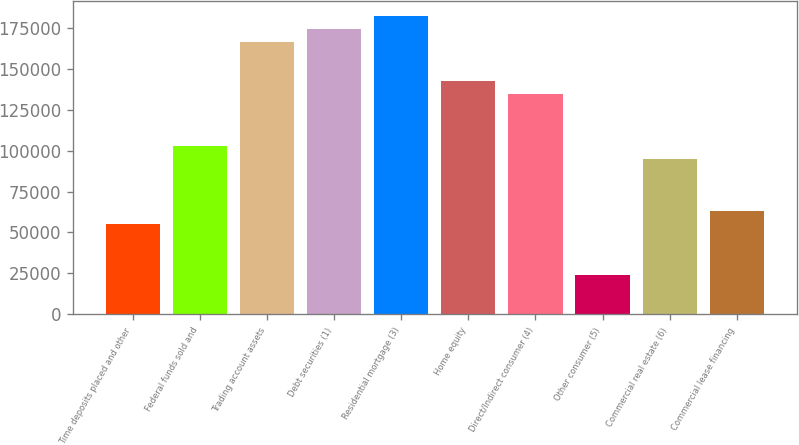Convert chart to OTSL. <chart><loc_0><loc_0><loc_500><loc_500><bar_chart><fcel>Time deposits placed and other<fcel>Federal funds sold and<fcel>Trading account assets<fcel>Debt securities (1)<fcel>Residential mortgage (3)<fcel>Home equity<fcel>Direct/Indirect consumer (4)<fcel>Other consumer (5)<fcel>Commercial real estate (6)<fcel>Commercial lease financing<nl><fcel>55457.3<fcel>102977<fcel>166336<fcel>174256<fcel>182176<fcel>142576<fcel>134656<fcel>23777.7<fcel>95056.8<fcel>63377.2<nl></chart> 